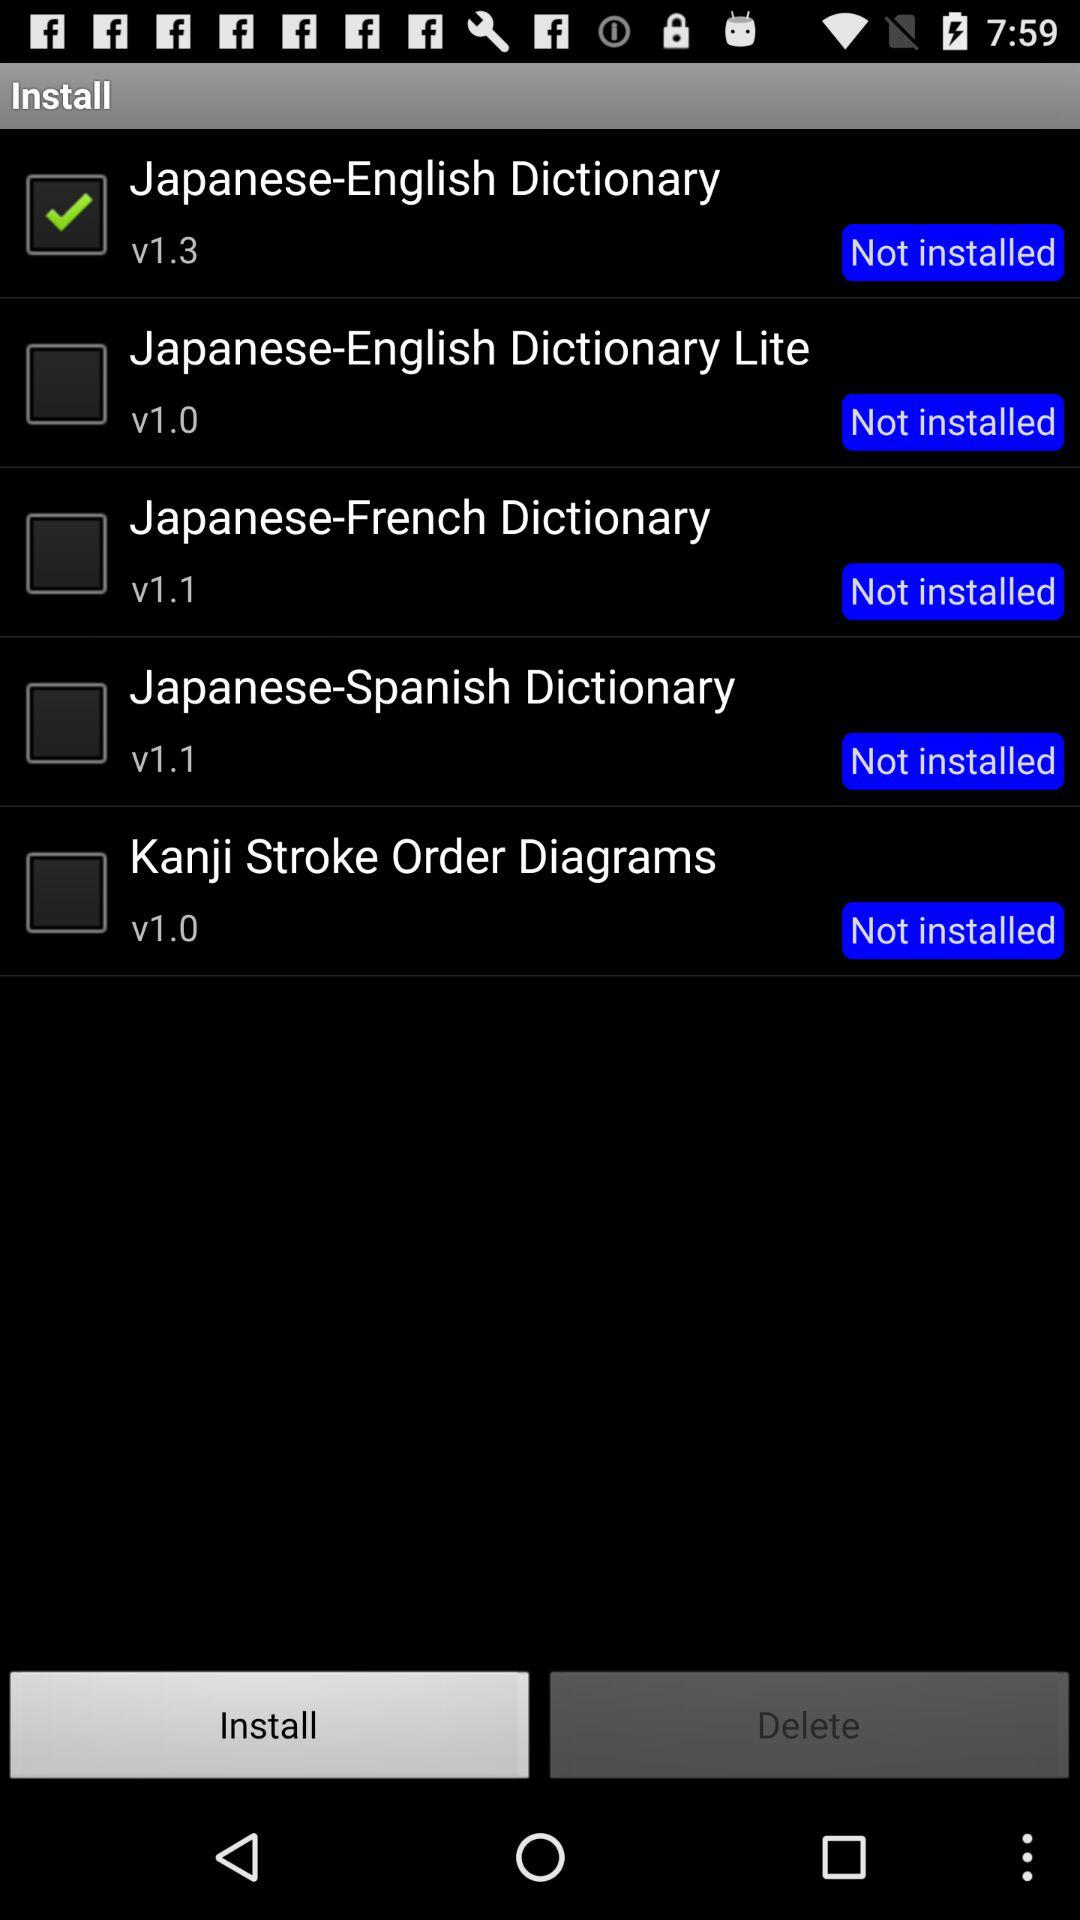How many dictionaries are available for installation?
Answer the question using a single word or phrase. 5 